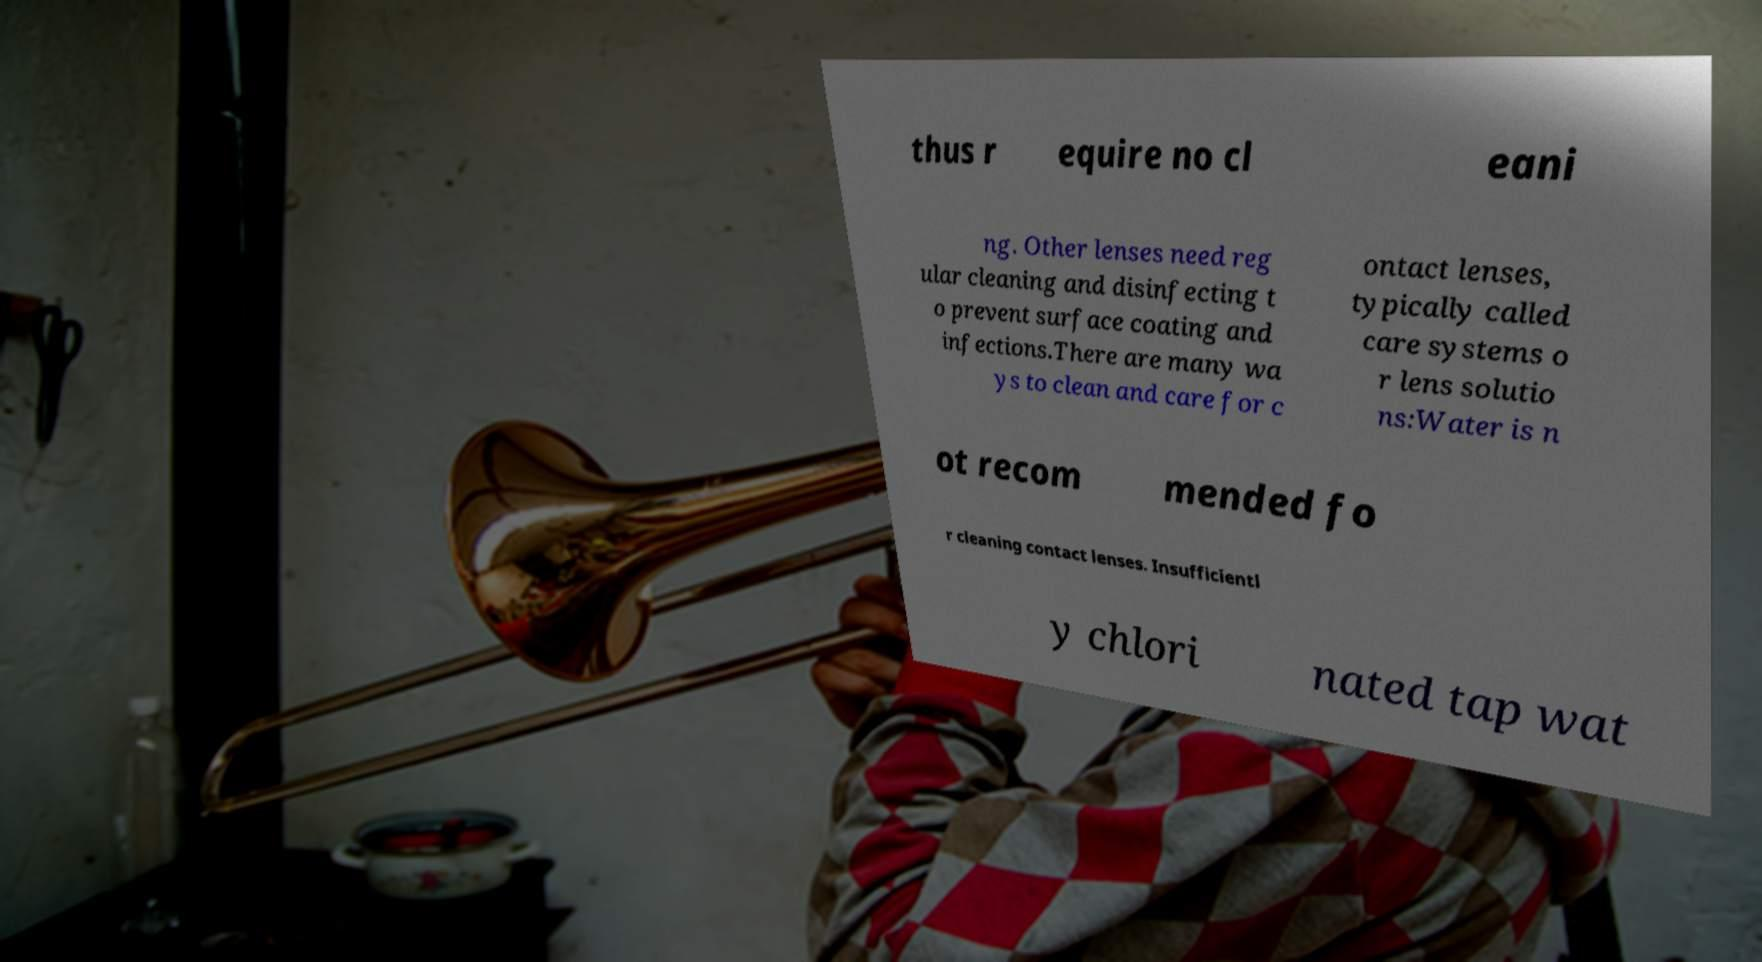Can you accurately transcribe the text from the provided image for me? thus r equire no cl eani ng. Other lenses need reg ular cleaning and disinfecting t o prevent surface coating and infections.There are many wa ys to clean and care for c ontact lenses, typically called care systems o r lens solutio ns:Water is n ot recom mended fo r cleaning contact lenses. Insufficientl y chlori nated tap wat 